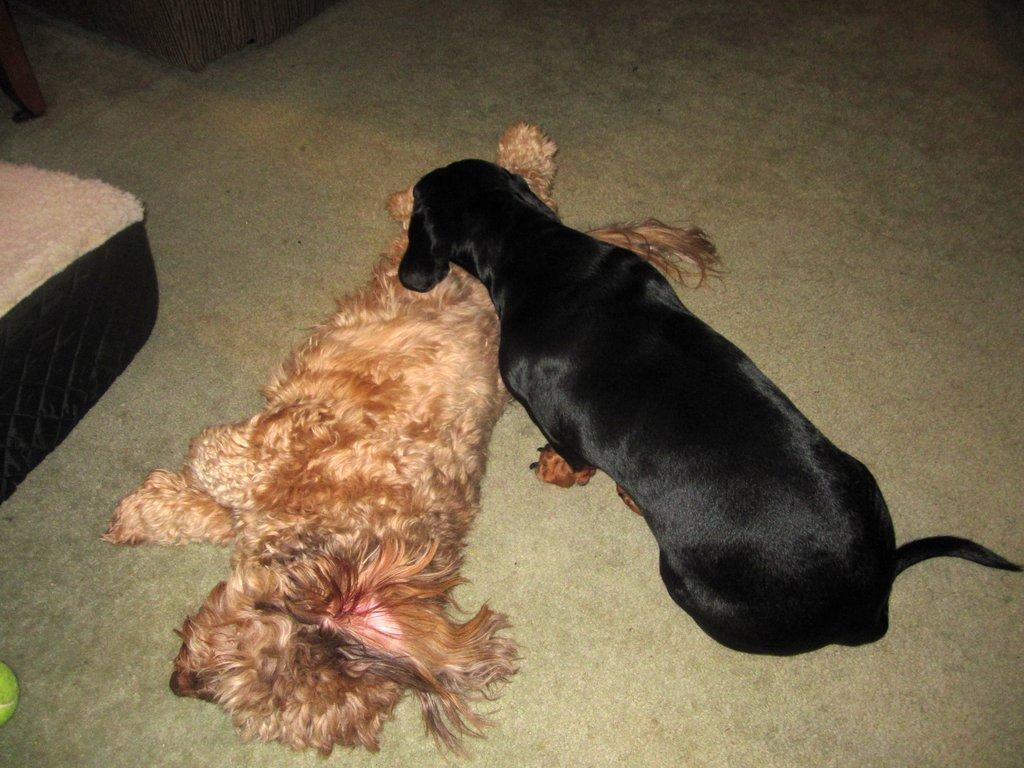How would you summarize this image in a sentence or two? In this image there are two dogs on the surface and there are few objects placed. 